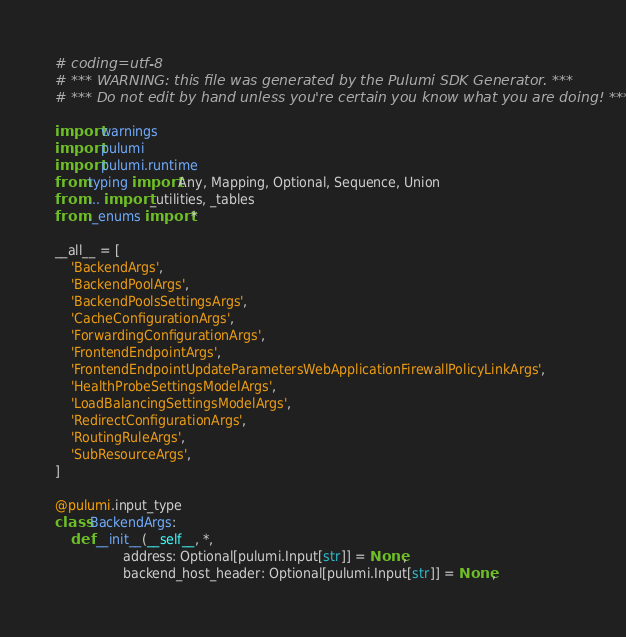<code> <loc_0><loc_0><loc_500><loc_500><_Python_># coding=utf-8
# *** WARNING: this file was generated by the Pulumi SDK Generator. ***
# *** Do not edit by hand unless you're certain you know what you are doing! ***

import warnings
import pulumi
import pulumi.runtime
from typing import Any, Mapping, Optional, Sequence, Union
from ... import _utilities, _tables
from ._enums import *

__all__ = [
    'BackendArgs',
    'BackendPoolArgs',
    'BackendPoolsSettingsArgs',
    'CacheConfigurationArgs',
    'ForwardingConfigurationArgs',
    'FrontendEndpointArgs',
    'FrontendEndpointUpdateParametersWebApplicationFirewallPolicyLinkArgs',
    'HealthProbeSettingsModelArgs',
    'LoadBalancingSettingsModelArgs',
    'RedirectConfigurationArgs',
    'RoutingRuleArgs',
    'SubResourceArgs',
]

@pulumi.input_type
class BackendArgs:
    def __init__(__self__, *,
                 address: Optional[pulumi.Input[str]] = None,
                 backend_host_header: Optional[pulumi.Input[str]] = None,</code> 